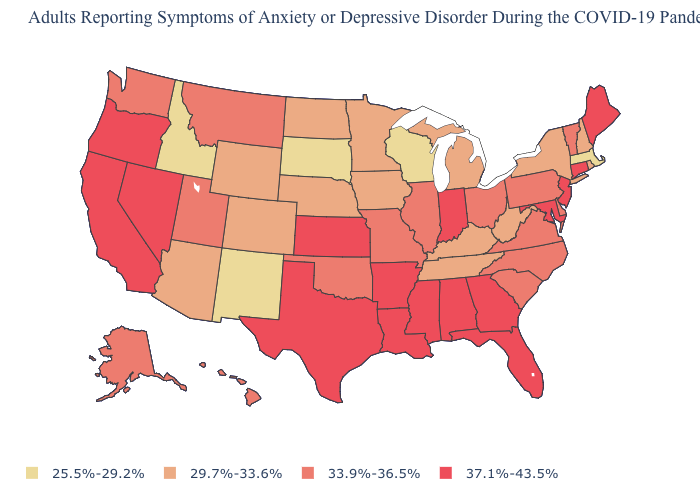Does West Virginia have the same value as Washington?
Keep it brief. No. What is the lowest value in the USA?
Give a very brief answer. 25.5%-29.2%. What is the value of Massachusetts?
Quick response, please. 25.5%-29.2%. What is the value of Vermont?
Quick response, please. 33.9%-36.5%. Does the first symbol in the legend represent the smallest category?
Write a very short answer. Yes. Which states hav the highest value in the MidWest?
Answer briefly. Indiana, Kansas. Name the states that have a value in the range 33.9%-36.5%?
Give a very brief answer. Alaska, Delaware, Hawaii, Illinois, Missouri, Montana, North Carolina, Ohio, Oklahoma, Pennsylvania, South Carolina, Utah, Vermont, Virginia, Washington. Does Wisconsin have the lowest value in the USA?
Write a very short answer. Yes. How many symbols are there in the legend?
Keep it brief. 4. Is the legend a continuous bar?
Short answer required. No. Does Illinois have a higher value than Wisconsin?
Short answer required. Yes. Name the states that have a value in the range 29.7%-33.6%?
Give a very brief answer. Arizona, Colorado, Iowa, Kentucky, Michigan, Minnesota, Nebraska, New Hampshire, New York, North Dakota, Rhode Island, Tennessee, West Virginia, Wyoming. Does Texas have the lowest value in the South?
Keep it brief. No. Does Rhode Island have the lowest value in the Northeast?
Answer briefly. No. What is the value of Mississippi?
Concise answer only. 37.1%-43.5%. 